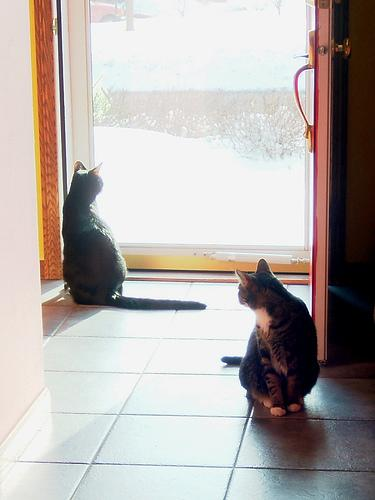What can be seen outside through the window or door in the image? A place full of snow, plants covered in snow, and a car parked in the snow can be seen outside through the window. Please mention the parts of the cats that can be observed in the image along with their positions. The left ear of the first cat, the right ear of the second cat, the right white paw of the first cat, the left white paw of the first cat, black tails of both cats, and a white patch on the first cat's neck can be observed. What emotions does this image evoke, and what aspects of the scene contribute to those feelings? The image evokes a sense of curiosity and coziness, as the cats seem intrigued by something outside and are comfortably staying inside the warmth of the house on the tiled floor. Explain the interaction between the objects present in the image. The cats are sitting on the tiled floor and looking outside through the window or door, while their shadows can be seen on the floor, and their tails are touching the floor. Describe the floor and the lighting in the image. The floor is made of square-shaped white tiles, with light shining on it and creating shadows of the cats. Identify the main elements in the picture along with their locations based on their image coordinates. There are two cats on the floor with black tails, one having a white patch on its neck and white paws, a wooden door with a golden door knob and red door handle, square-shaped tiled floor, and snow outside visible through a large window. Provide a detailed description of the door in the image. The door is made of wood, has a large window, a golden door knob, and a red handle. It is the entrance to the house and allows light to shine through. What is the main focus of the image and what makes it interesting? The main focus of the image is the two cats, situated on the tiled floor of the house, and looking out of the door or window. The combination of their curiosity and the cozy indoor setting make the image interesting. Describe the actions of the two cats in the image. One cat is sitting and looking out through the window, while the other cat has its head facing behind, both situated on the tiled floor. How many cats are there in the image, and what are their colors? There are two cats in the image. One is a gray, black, and white cat, and the other is a black cat. Can you notice a rug under the cats? The image mentions a tiled floor under the cats; suggesting a rug instead will be misleading. Does the door handle have a silver color? The image has a golden door knob and a brass door handle, introducing a silver door handle will be misleading. Can you see a bird sitting on the window in the door? The image focuses on cats and other objects, but there is no mention of a bird on the window. Introducing this new element can be misleading. Is there a third cat hidden behind the first two cats? The image has only two cats mentioned with their features described, suggesting the presence of a third cat can be misleading. Is one of the cats standing on its hind legs? The image describes the positions and features of the cats, but none of them are mentioned as standing on their hind legs. Suggesting this can be misleading. Is the car parked in the snow a red color? The image contains a car parked in the snow, but there is no mention of its color, so suggesting that it is red could be misleading. 